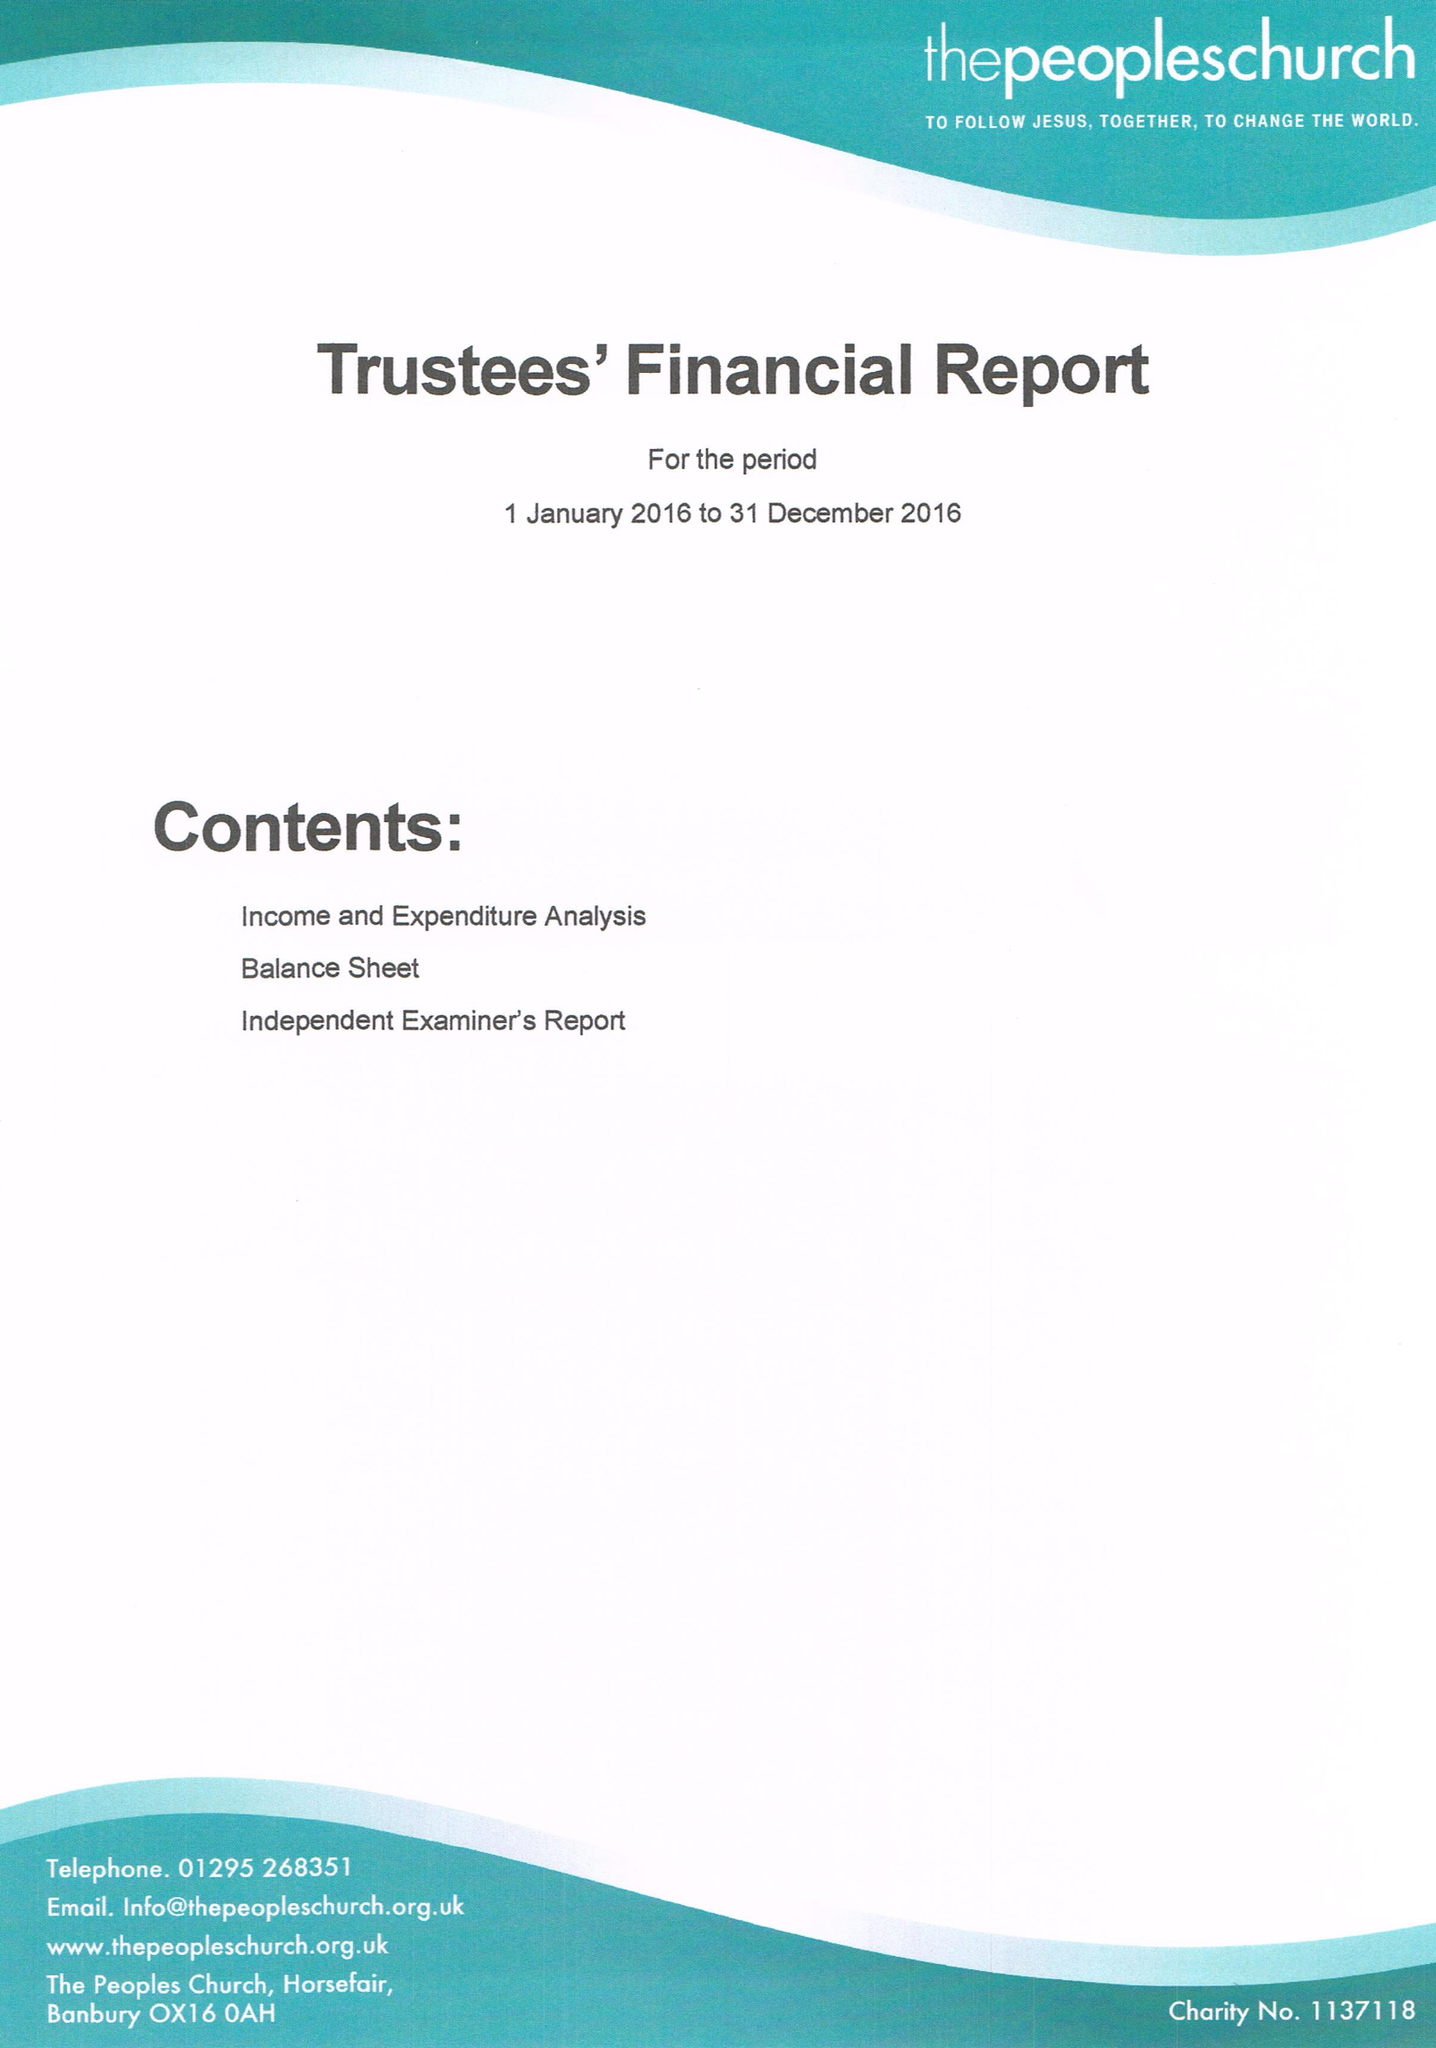What is the value for the report_date?
Answer the question using a single word or phrase. 2016-12-31 